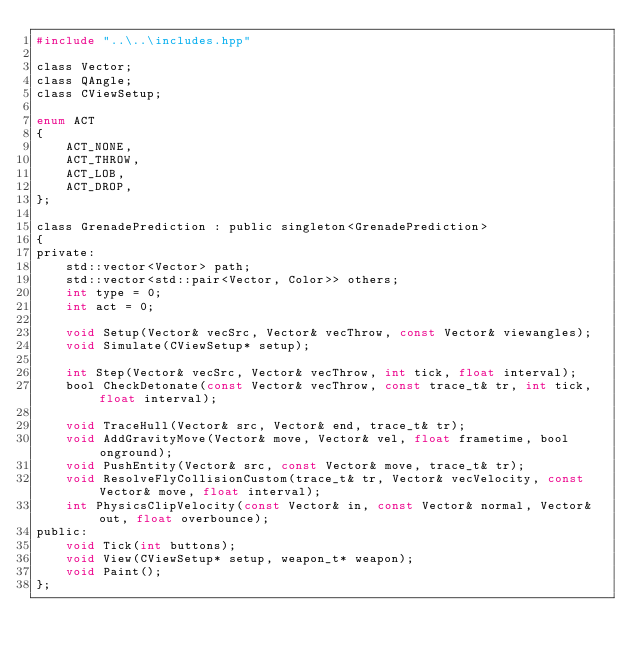<code> <loc_0><loc_0><loc_500><loc_500><_C_>#include "..\..\includes.hpp"

class Vector;
class QAngle;
class CViewSetup;

enum ACT
{
	ACT_NONE,
	ACT_THROW,
	ACT_LOB,
	ACT_DROP,
};

class GrenadePrediction : public singleton<GrenadePrediction>
{
private:
	std::vector<Vector> path;
	std::vector<std::pair<Vector, Color>> others;
	int type = 0;
	int act = 0;

	void Setup(Vector& vecSrc, Vector& vecThrow, const Vector& viewangles);
	void Simulate(CViewSetup* setup);

	int Step(Vector& vecSrc, Vector& vecThrow, int tick, float interval);
	bool CheckDetonate(const Vector& vecThrow, const trace_t& tr, int tick, float interval);

	void TraceHull(Vector& src, Vector& end, trace_t& tr);
	void AddGravityMove(Vector& move, Vector& vel, float frametime, bool onground);
	void PushEntity(Vector& src, const Vector& move, trace_t& tr);
	void ResolveFlyCollisionCustom(trace_t& tr, Vector& vecVelocity, const Vector& move, float interval);
	int PhysicsClipVelocity(const Vector& in, const Vector& normal, Vector& out, float overbounce);
public:
	void Tick(int buttons);
	void View(CViewSetup* setup, weapon_t* weapon);
	void Paint();
};</code> 